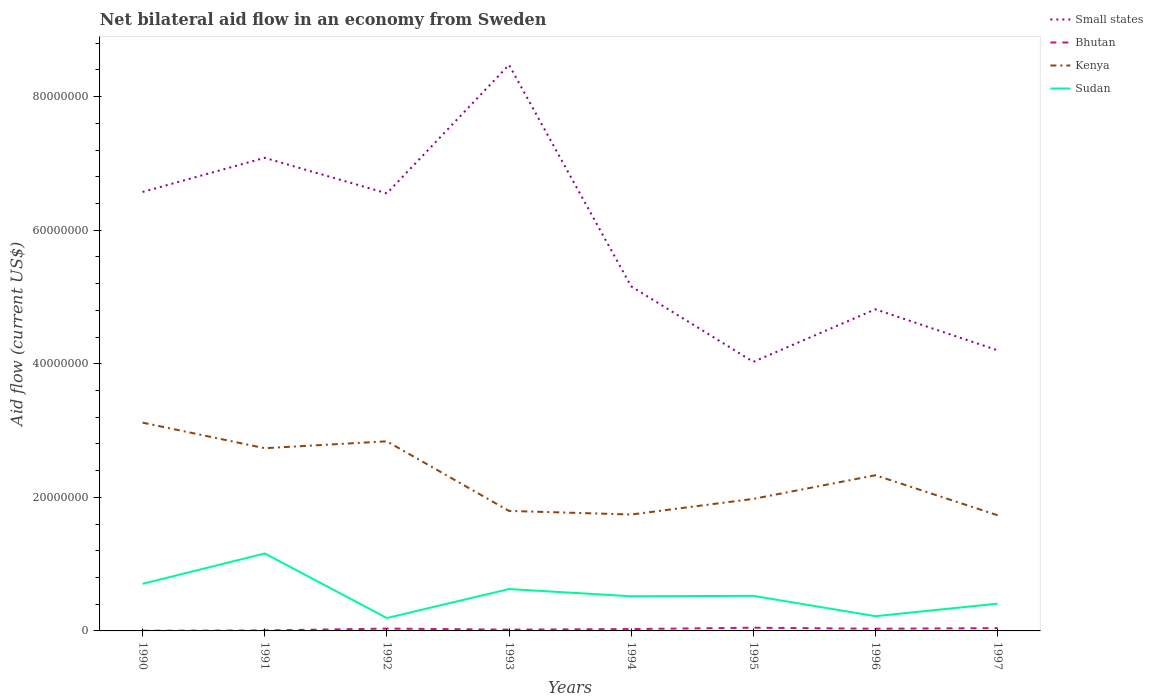Across all years, what is the maximum net bilateral aid flow in Small states?
Make the answer very short. 4.03e+07. What is the total net bilateral aid flow in Kenya in the graph?
Keep it short and to the point. 5.40e+05. What is the difference between the highest and the second highest net bilateral aid flow in Kenya?
Ensure brevity in your answer.  1.39e+07. What is the difference between the highest and the lowest net bilateral aid flow in Sudan?
Offer a very short reply. 3. How many lines are there?
Provide a succinct answer. 4. Where does the legend appear in the graph?
Keep it short and to the point. Top right. How are the legend labels stacked?
Keep it short and to the point. Vertical. What is the title of the graph?
Keep it short and to the point. Net bilateral aid flow in an economy from Sweden. What is the Aid flow (current US$) in Small states in 1990?
Your answer should be very brief. 6.57e+07. What is the Aid flow (current US$) of Bhutan in 1990?
Your answer should be compact. 3.00e+04. What is the Aid flow (current US$) in Kenya in 1990?
Your response must be concise. 3.12e+07. What is the Aid flow (current US$) in Sudan in 1990?
Your response must be concise. 7.05e+06. What is the Aid flow (current US$) in Small states in 1991?
Your answer should be compact. 7.08e+07. What is the Aid flow (current US$) of Bhutan in 1991?
Provide a succinct answer. 7.00e+04. What is the Aid flow (current US$) of Kenya in 1991?
Offer a terse response. 2.74e+07. What is the Aid flow (current US$) in Sudan in 1991?
Provide a succinct answer. 1.16e+07. What is the Aid flow (current US$) in Small states in 1992?
Keep it short and to the point. 6.55e+07. What is the Aid flow (current US$) in Kenya in 1992?
Give a very brief answer. 2.84e+07. What is the Aid flow (current US$) in Sudan in 1992?
Give a very brief answer. 1.93e+06. What is the Aid flow (current US$) in Small states in 1993?
Provide a short and direct response. 8.48e+07. What is the Aid flow (current US$) of Kenya in 1993?
Your response must be concise. 1.80e+07. What is the Aid flow (current US$) in Sudan in 1993?
Offer a terse response. 6.27e+06. What is the Aid flow (current US$) in Small states in 1994?
Offer a terse response. 5.16e+07. What is the Aid flow (current US$) in Bhutan in 1994?
Offer a terse response. 2.80e+05. What is the Aid flow (current US$) of Kenya in 1994?
Provide a succinct answer. 1.74e+07. What is the Aid flow (current US$) in Sudan in 1994?
Provide a succinct answer. 5.19e+06. What is the Aid flow (current US$) of Small states in 1995?
Your answer should be very brief. 4.03e+07. What is the Aid flow (current US$) of Bhutan in 1995?
Make the answer very short. 4.80e+05. What is the Aid flow (current US$) of Kenya in 1995?
Your answer should be very brief. 1.98e+07. What is the Aid flow (current US$) of Sudan in 1995?
Offer a very short reply. 5.25e+06. What is the Aid flow (current US$) of Small states in 1996?
Provide a succinct answer. 4.82e+07. What is the Aid flow (current US$) of Bhutan in 1996?
Keep it short and to the point. 3.30e+05. What is the Aid flow (current US$) in Kenya in 1996?
Ensure brevity in your answer.  2.33e+07. What is the Aid flow (current US$) of Sudan in 1996?
Offer a very short reply. 2.21e+06. What is the Aid flow (current US$) in Small states in 1997?
Give a very brief answer. 4.20e+07. What is the Aid flow (current US$) in Bhutan in 1997?
Your response must be concise. 4.20e+05. What is the Aid flow (current US$) in Kenya in 1997?
Your answer should be compact. 1.73e+07. What is the Aid flow (current US$) in Sudan in 1997?
Your answer should be very brief. 4.08e+06. Across all years, what is the maximum Aid flow (current US$) in Small states?
Ensure brevity in your answer.  8.48e+07. Across all years, what is the maximum Aid flow (current US$) of Bhutan?
Your answer should be very brief. 4.80e+05. Across all years, what is the maximum Aid flow (current US$) in Kenya?
Your answer should be very brief. 3.12e+07. Across all years, what is the maximum Aid flow (current US$) of Sudan?
Keep it short and to the point. 1.16e+07. Across all years, what is the minimum Aid flow (current US$) in Small states?
Make the answer very short. 4.03e+07. Across all years, what is the minimum Aid flow (current US$) in Kenya?
Your answer should be compact. 1.73e+07. Across all years, what is the minimum Aid flow (current US$) in Sudan?
Make the answer very short. 1.93e+06. What is the total Aid flow (current US$) of Small states in the graph?
Your response must be concise. 4.69e+08. What is the total Aid flow (current US$) in Bhutan in the graph?
Offer a terse response. 2.15e+06. What is the total Aid flow (current US$) in Kenya in the graph?
Your response must be concise. 1.83e+08. What is the total Aid flow (current US$) of Sudan in the graph?
Your answer should be compact. 4.36e+07. What is the difference between the Aid flow (current US$) in Small states in 1990 and that in 1991?
Provide a short and direct response. -5.11e+06. What is the difference between the Aid flow (current US$) of Kenya in 1990 and that in 1991?
Your answer should be very brief. 3.83e+06. What is the difference between the Aid flow (current US$) in Sudan in 1990 and that in 1991?
Provide a succinct answer. -4.55e+06. What is the difference between the Aid flow (current US$) in Small states in 1990 and that in 1992?
Your answer should be very brief. 2.10e+05. What is the difference between the Aid flow (current US$) in Bhutan in 1990 and that in 1992?
Make the answer very short. -3.20e+05. What is the difference between the Aid flow (current US$) of Kenya in 1990 and that in 1992?
Ensure brevity in your answer.  2.80e+06. What is the difference between the Aid flow (current US$) in Sudan in 1990 and that in 1992?
Offer a terse response. 5.12e+06. What is the difference between the Aid flow (current US$) of Small states in 1990 and that in 1993?
Ensure brevity in your answer.  -1.90e+07. What is the difference between the Aid flow (current US$) in Kenya in 1990 and that in 1993?
Provide a short and direct response. 1.32e+07. What is the difference between the Aid flow (current US$) in Sudan in 1990 and that in 1993?
Give a very brief answer. 7.80e+05. What is the difference between the Aid flow (current US$) in Small states in 1990 and that in 1994?
Offer a terse response. 1.41e+07. What is the difference between the Aid flow (current US$) in Bhutan in 1990 and that in 1994?
Your response must be concise. -2.50e+05. What is the difference between the Aid flow (current US$) of Kenya in 1990 and that in 1994?
Offer a terse response. 1.38e+07. What is the difference between the Aid flow (current US$) of Sudan in 1990 and that in 1994?
Make the answer very short. 1.86e+06. What is the difference between the Aid flow (current US$) in Small states in 1990 and that in 1995?
Keep it short and to the point. 2.54e+07. What is the difference between the Aid flow (current US$) in Bhutan in 1990 and that in 1995?
Your response must be concise. -4.50e+05. What is the difference between the Aid flow (current US$) of Kenya in 1990 and that in 1995?
Give a very brief answer. 1.14e+07. What is the difference between the Aid flow (current US$) of Sudan in 1990 and that in 1995?
Make the answer very short. 1.80e+06. What is the difference between the Aid flow (current US$) in Small states in 1990 and that in 1996?
Make the answer very short. 1.76e+07. What is the difference between the Aid flow (current US$) in Kenya in 1990 and that in 1996?
Ensure brevity in your answer.  7.88e+06. What is the difference between the Aid flow (current US$) in Sudan in 1990 and that in 1996?
Your answer should be compact. 4.84e+06. What is the difference between the Aid flow (current US$) in Small states in 1990 and that in 1997?
Offer a very short reply. 2.37e+07. What is the difference between the Aid flow (current US$) in Bhutan in 1990 and that in 1997?
Your response must be concise. -3.90e+05. What is the difference between the Aid flow (current US$) in Kenya in 1990 and that in 1997?
Your answer should be compact. 1.39e+07. What is the difference between the Aid flow (current US$) of Sudan in 1990 and that in 1997?
Provide a succinct answer. 2.97e+06. What is the difference between the Aid flow (current US$) in Small states in 1991 and that in 1992?
Provide a succinct answer. 5.32e+06. What is the difference between the Aid flow (current US$) of Bhutan in 1991 and that in 1992?
Make the answer very short. -2.80e+05. What is the difference between the Aid flow (current US$) in Kenya in 1991 and that in 1992?
Keep it short and to the point. -1.03e+06. What is the difference between the Aid flow (current US$) in Sudan in 1991 and that in 1992?
Provide a succinct answer. 9.67e+06. What is the difference between the Aid flow (current US$) of Small states in 1991 and that in 1993?
Offer a terse response. -1.39e+07. What is the difference between the Aid flow (current US$) in Bhutan in 1991 and that in 1993?
Your response must be concise. -1.20e+05. What is the difference between the Aid flow (current US$) of Kenya in 1991 and that in 1993?
Ensure brevity in your answer.  9.39e+06. What is the difference between the Aid flow (current US$) of Sudan in 1991 and that in 1993?
Keep it short and to the point. 5.33e+06. What is the difference between the Aid flow (current US$) in Small states in 1991 and that in 1994?
Offer a terse response. 1.92e+07. What is the difference between the Aid flow (current US$) in Kenya in 1991 and that in 1994?
Your answer should be very brief. 9.93e+06. What is the difference between the Aid flow (current US$) in Sudan in 1991 and that in 1994?
Your answer should be compact. 6.41e+06. What is the difference between the Aid flow (current US$) in Small states in 1991 and that in 1995?
Ensure brevity in your answer.  3.06e+07. What is the difference between the Aid flow (current US$) of Bhutan in 1991 and that in 1995?
Offer a terse response. -4.10e+05. What is the difference between the Aid flow (current US$) of Kenya in 1991 and that in 1995?
Provide a succinct answer. 7.59e+06. What is the difference between the Aid flow (current US$) in Sudan in 1991 and that in 1995?
Provide a short and direct response. 6.35e+06. What is the difference between the Aid flow (current US$) of Small states in 1991 and that in 1996?
Your answer should be very brief. 2.27e+07. What is the difference between the Aid flow (current US$) of Bhutan in 1991 and that in 1996?
Your response must be concise. -2.60e+05. What is the difference between the Aid flow (current US$) in Kenya in 1991 and that in 1996?
Give a very brief answer. 4.05e+06. What is the difference between the Aid flow (current US$) in Sudan in 1991 and that in 1996?
Your answer should be very brief. 9.39e+06. What is the difference between the Aid flow (current US$) in Small states in 1991 and that in 1997?
Offer a terse response. 2.88e+07. What is the difference between the Aid flow (current US$) in Bhutan in 1991 and that in 1997?
Offer a terse response. -3.50e+05. What is the difference between the Aid flow (current US$) of Kenya in 1991 and that in 1997?
Make the answer very short. 1.00e+07. What is the difference between the Aid flow (current US$) in Sudan in 1991 and that in 1997?
Offer a very short reply. 7.52e+06. What is the difference between the Aid flow (current US$) of Small states in 1992 and that in 1993?
Your answer should be very brief. -1.92e+07. What is the difference between the Aid flow (current US$) of Kenya in 1992 and that in 1993?
Your answer should be very brief. 1.04e+07. What is the difference between the Aid flow (current US$) of Sudan in 1992 and that in 1993?
Offer a terse response. -4.34e+06. What is the difference between the Aid flow (current US$) in Small states in 1992 and that in 1994?
Provide a short and direct response. 1.39e+07. What is the difference between the Aid flow (current US$) of Kenya in 1992 and that in 1994?
Your answer should be very brief. 1.10e+07. What is the difference between the Aid flow (current US$) in Sudan in 1992 and that in 1994?
Provide a short and direct response. -3.26e+06. What is the difference between the Aid flow (current US$) of Small states in 1992 and that in 1995?
Offer a terse response. 2.52e+07. What is the difference between the Aid flow (current US$) in Bhutan in 1992 and that in 1995?
Ensure brevity in your answer.  -1.30e+05. What is the difference between the Aid flow (current US$) in Kenya in 1992 and that in 1995?
Your answer should be compact. 8.62e+06. What is the difference between the Aid flow (current US$) of Sudan in 1992 and that in 1995?
Give a very brief answer. -3.32e+06. What is the difference between the Aid flow (current US$) in Small states in 1992 and that in 1996?
Provide a short and direct response. 1.74e+07. What is the difference between the Aid flow (current US$) in Kenya in 1992 and that in 1996?
Offer a terse response. 5.08e+06. What is the difference between the Aid flow (current US$) in Sudan in 1992 and that in 1996?
Offer a terse response. -2.80e+05. What is the difference between the Aid flow (current US$) of Small states in 1992 and that in 1997?
Make the answer very short. 2.35e+07. What is the difference between the Aid flow (current US$) in Bhutan in 1992 and that in 1997?
Offer a terse response. -7.00e+04. What is the difference between the Aid flow (current US$) in Kenya in 1992 and that in 1997?
Offer a very short reply. 1.11e+07. What is the difference between the Aid flow (current US$) in Sudan in 1992 and that in 1997?
Provide a short and direct response. -2.15e+06. What is the difference between the Aid flow (current US$) of Small states in 1993 and that in 1994?
Your answer should be very brief. 3.32e+07. What is the difference between the Aid flow (current US$) of Bhutan in 1993 and that in 1994?
Provide a short and direct response. -9.00e+04. What is the difference between the Aid flow (current US$) in Kenya in 1993 and that in 1994?
Make the answer very short. 5.40e+05. What is the difference between the Aid flow (current US$) of Sudan in 1993 and that in 1994?
Provide a short and direct response. 1.08e+06. What is the difference between the Aid flow (current US$) in Small states in 1993 and that in 1995?
Ensure brevity in your answer.  4.45e+07. What is the difference between the Aid flow (current US$) of Bhutan in 1993 and that in 1995?
Offer a terse response. -2.90e+05. What is the difference between the Aid flow (current US$) in Kenya in 1993 and that in 1995?
Make the answer very short. -1.80e+06. What is the difference between the Aid flow (current US$) of Sudan in 1993 and that in 1995?
Provide a succinct answer. 1.02e+06. What is the difference between the Aid flow (current US$) of Small states in 1993 and that in 1996?
Provide a short and direct response. 3.66e+07. What is the difference between the Aid flow (current US$) in Kenya in 1993 and that in 1996?
Make the answer very short. -5.34e+06. What is the difference between the Aid flow (current US$) in Sudan in 1993 and that in 1996?
Your answer should be very brief. 4.06e+06. What is the difference between the Aid flow (current US$) of Small states in 1993 and that in 1997?
Your response must be concise. 4.27e+07. What is the difference between the Aid flow (current US$) of Kenya in 1993 and that in 1997?
Offer a very short reply. 6.50e+05. What is the difference between the Aid flow (current US$) of Sudan in 1993 and that in 1997?
Your answer should be very brief. 2.19e+06. What is the difference between the Aid flow (current US$) of Small states in 1994 and that in 1995?
Your answer should be compact. 1.13e+07. What is the difference between the Aid flow (current US$) of Kenya in 1994 and that in 1995?
Offer a very short reply. -2.34e+06. What is the difference between the Aid flow (current US$) in Small states in 1994 and that in 1996?
Keep it short and to the point. 3.44e+06. What is the difference between the Aid flow (current US$) in Kenya in 1994 and that in 1996?
Provide a short and direct response. -5.88e+06. What is the difference between the Aid flow (current US$) in Sudan in 1994 and that in 1996?
Provide a succinct answer. 2.98e+06. What is the difference between the Aid flow (current US$) in Small states in 1994 and that in 1997?
Offer a very short reply. 9.58e+06. What is the difference between the Aid flow (current US$) in Bhutan in 1994 and that in 1997?
Provide a succinct answer. -1.40e+05. What is the difference between the Aid flow (current US$) of Sudan in 1994 and that in 1997?
Your answer should be very brief. 1.11e+06. What is the difference between the Aid flow (current US$) in Small states in 1995 and that in 1996?
Ensure brevity in your answer.  -7.87e+06. What is the difference between the Aid flow (current US$) in Kenya in 1995 and that in 1996?
Your answer should be very brief. -3.54e+06. What is the difference between the Aid flow (current US$) of Sudan in 1995 and that in 1996?
Provide a succinct answer. 3.04e+06. What is the difference between the Aid flow (current US$) of Small states in 1995 and that in 1997?
Your response must be concise. -1.73e+06. What is the difference between the Aid flow (current US$) of Bhutan in 1995 and that in 1997?
Your response must be concise. 6.00e+04. What is the difference between the Aid flow (current US$) of Kenya in 1995 and that in 1997?
Provide a short and direct response. 2.45e+06. What is the difference between the Aid flow (current US$) of Sudan in 1995 and that in 1997?
Keep it short and to the point. 1.17e+06. What is the difference between the Aid flow (current US$) of Small states in 1996 and that in 1997?
Give a very brief answer. 6.14e+06. What is the difference between the Aid flow (current US$) of Bhutan in 1996 and that in 1997?
Ensure brevity in your answer.  -9.00e+04. What is the difference between the Aid flow (current US$) of Kenya in 1996 and that in 1997?
Keep it short and to the point. 5.99e+06. What is the difference between the Aid flow (current US$) in Sudan in 1996 and that in 1997?
Provide a short and direct response. -1.87e+06. What is the difference between the Aid flow (current US$) of Small states in 1990 and the Aid flow (current US$) of Bhutan in 1991?
Provide a succinct answer. 6.57e+07. What is the difference between the Aid flow (current US$) in Small states in 1990 and the Aid flow (current US$) in Kenya in 1991?
Offer a very short reply. 3.84e+07. What is the difference between the Aid flow (current US$) of Small states in 1990 and the Aid flow (current US$) of Sudan in 1991?
Give a very brief answer. 5.41e+07. What is the difference between the Aid flow (current US$) of Bhutan in 1990 and the Aid flow (current US$) of Kenya in 1991?
Offer a terse response. -2.73e+07. What is the difference between the Aid flow (current US$) in Bhutan in 1990 and the Aid flow (current US$) in Sudan in 1991?
Keep it short and to the point. -1.16e+07. What is the difference between the Aid flow (current US$) in Kenya in 1990 and the Aid flow (current US$) in Sudan in 1991?
Provide a short and direct response. 1.96e+07. What is the difference between the Aid flow (current US$) of Small states in 1990 and the Aid flow (current US$) of Bhutan in 1992?
Make the answer very short. 6.54e+07. What is the difference between the Aid flow (current US$) of Small states in 1990 and the Aid flow (current US$) of Kenya in 1992?
Your answer should be compact. 3.73e+07. What is the difference between the Aid flow (current US$) in Small states in 1990 and the Aid flow (current US$) in Sudan in 1992?
Keep it short and to the point. 6.38e+07. What is the difference between the Aid flow (current US$) of Bhutan in 1990 and the Aid flow (current US$) of Kenya in 1992?
Make the answer very short. -2.84e+07. What is the difference between the Aid flow (current US$) of Bhutan in 1990 and the Aid flow (current US$) of Sudan in 1992?
Provide a short and direct response. -1.90e+06. What is the difference between the Aid flow (current US$) in Kenya in 1990 and the Aid flow (current US$) in Sudan in 1992?
Give a very brief answer. 2.93e+07. What is the difference between the Aid flow (current US$) in Small states in 1990 and the Aid flow (current US$) in Bhutan in 1993?
Keep it short and to the point. 6.55e+07. What is the difference between the Aid flow (current US$) of Small states in 1990 and the Aid flow (current US$) of Kenya in 1993?
Keep it short and to the point. 4.78e+07. What is the difference between the Aid flow (current US$) in Small states in 1990 and the Aid flow (current US$) in Sudan in 1993?
Provide a short and direct response. 5.95e+07. What is the difference between the Aid flow (current US$) of Bhutan in 1990 and the Aid flow (current US$) of Kenya in 1993?
Offer a terse response. -1.79e+07. What is the difference between the Aid flow (current US$) in Bhutan in 1990 and the Aid flow (current US$) in Sudan in 1993?
Your response must be concise. -6.24e+06. What is the difference between the Aid flow (current US$) in Kenya in 1990 and the Aid flow (current US$) in Sudan in 1993?
Offer a very short reply. 2.49e+07. What is the difference between the Aid flow (current US$) of Small states in 1990 and the Aid flow (current US$) of Bhutan in 1994?
Make the answer very short. 6.54e+07. What is the difference between the Aid flow (current US$) of Small states in 1990 and the Aid flow (current US$) of Kenya in 1994?
Give a very brief answer. 4.83e+07. What is the difference between the Aid flow (current US$) of Small states in 1990 and the Aid flow (current US$) of Sudan in 1994?
Ensure brevity in your answer.  6.05e+07. What is the difference between the Aid flow (current US$) of Bhutan in 1990 and the Aid flow (current US$) of Kenya in 1994?
Give a very brief answer. -1.74e+07. What is the difference between the Aid flow (current US$) of Bhutan in 1990 and the Aid flow (current US$) of Sudan in 1994?
Offer a terse response. -5.16e+06. What is the difference between the Aid flow (current US$) of Kenya in 1990 and the Aid flow (current US$) of Sudan in 1994?
Your response must be concise. 2.60e+07. What is the difference between the Aid flow (current US$) in Small states in 1990 and the Aid flow (current US$) in Bhutan in 1995?
Offer a terse response. 6.52e+07. What is the difference between the Aid flow (current US$) in Small states in 1990 and the Aid flow (current US$) in Kenya in 1995?
Your answer should be very brief. 4.60e+07. What is the difference between the Aid flow (current US$) of Small states in 1990 and the Aid flow (current US$) of Sudan in 1995?
Ensure brevity in your answer.  6.05e+07. What is the difference between the Aid flow (current US$) in Bhutan in 1990 and the Aid flow (current US$) in Kenya in 1995?
Ensure brevity in your answer.  -1.97e+07. What is the difference between the Aid flow (current US$) in Bhutan in 1990 and the Aid flow (current US$) in Sudan in 1995?
Give a very brief answer. -5.22e+06. What is the difference between the Aid flow (current US$) of Kenya in 1990 and the Aid flow (current US$) of Sudan in 1995?
Provide a short and direct response. 2.59e+07. What is the difference between the Aid flow (current US$) in Small states in 1990 and the Aid flow (current US$) in Bhutan in 1996?
Keep it short and to the point. 6.54e+07. What is the difference between the Aid flow (current US$) in Small states in 1990 and the Aid flow (current US$) in Kenya in 1996?
Provide a succinct answer. 4.24e+07. What is the difference between the Aid flow (current US$) of Small states in 1990 and the Aid flow (current US$) of Sudan in 1996?
Your response must be concise. 6.35e+07. What is the difference between the Aid flow (current US$) in Bhutan in 1990 and the Aid flow (current US$) in Kenya in 1996?
Your answer should be compact. -2.33e+07. What is the difference between the Aid flow (current US$) in Bhutan in 1990 and the Aid flow (current US$) in Sudan in 1996?
Provide a succinct answer. -2.18e+06. What is the difference between the Aid flow (current US$) in Kenya in 1990 and the Aid flow (current US$) in Sudan in 1996?
Make the answer very short. 2.90e+07. What is the difference between the Aid flow (current US$) of Small states in 1990 and the Aid flow (current US$) of Bhutan in 1997?
Ensure brevity in your answer.  6.53e+07. What is the difference between the Aid flow (current US$) of Small states in 1990 and the Aid flow (current US$) of Kenya in 1997?
Offer a terse response. 4.84e+07. What is the difference between the Aid flow (current US$) of Small states in 1990 and the Aid flow (current US$) of Sudan in 1997?
Make the answer very short. 6.16e+07. What is the difference between the Aid flow (current US$) in Bhutan in 1990 and the Aid flow (current US$) in Kenya in 1997?
Ensure brevity in your answer.  -1.73e+07. What is the difference between the Aid flow (current US$) of Bhutan in 1990 and the Aid flow (current US$) of Sudan in 1997?
Your answer should be very brief. -4.05e+06. What is the difference between the Aid flow (current US$) of Kenya in 1990 and the Aid flow (current US$) of Sudan in 1997?
Give a very brief answer. 2.71e+07. What is the difference between the Aid flow (current US$) in Small states in 1991 and the Aid flow (current US$) in Bhutan in 1992?
Provide a succinct answer. 7.05e+07. What is the difference between the Aid flow (current US$) in Small states in 1991 and the Aid flow (current US$) in Kenya in 1992?
Your answer should be very brief. 4.24e+07. What is the difference between the Aid flow (current US$) in Small states in 1991 and the Aid flow (current US$) in Sudan in 1992?
Provide a short and direct response. 6.89e+07. What is the difference between the Aid flow (current US$) of Bhutan in 1991 and the Aid flow (current US$) of Kenya in 1992?
Keep it short and to the point. -2.83e+07. What is the difference between the Aid flow (current US$) of Bhutan in 1991 and the Aid flow (current US$) of Sudan in 1992?
Offer a very short reply. -1.86e+06. What is the difference between the Aid flow (current US$) of Kenya in 1991 and the Aid flow (current US$) of Sudan in 1992?
Provide a succinct answer. 2.54e+07. What is the difference between the Aid flow (current US$) of Small states in 1991 and the Aid flow (current US$) of Bhutan in 1993?
Keep it short and to the point. 7.06e+07. What is the difference between the Aid flow (current US$) of Small states in 1991 and the Aid flow (current US$) of Kenya in 1993?
Give a very brief answer. 5.29e+07. What is the difference between the Aid flow (current US$) in Small states in 1991 and the Aid flow (current US$) in Sudan in 1993?
Provide a short and direct response. 6.46e+07. What is the difference between the Aid flow (current US$) of Bhutan in 1991 and the Aid flow (current US$) of Kenya in 1993?
Your answer should be compact. -1.79e+07. What is the difference between the Aid flow (current US$) in Bhutan in 1991 and the Aid flow (current US$) in Sudan in 1993?
Your answer should be compact. -6.20e+06. What is the difference between the Aid flow (current US$) of Kenya in 1991 and the Aid flow (current US$) of Sudan in 1993?
Make the answer very short. 2.11e+07. What is the difference between the Aid flow (current US$) of Small states in 1991 and the Aid flow (current US$) of Bhutan in 1994?
Your answer should be very brief. 7.06e+07. What is the difference between the Aid flow (current US$) in Small states in 1991 and the Aid flow (current US$) in Kenya in 1994?
Give a very brief answer. 5.34e+07. What is the difference between the Aid flow (current US$) of Small states in 1991 and the Aid flow (current US$) of Sudan in 1994?
Ensure brevity in your answer.  6.56e+07. What is the difference between the Aid flow (current US$) of Bhutan in 1991 and the Aid flow (current US$) of Kenya in 1994?
Your response must be concise. -1.74e+07. What is the difference between the Aid flow (current US$) of Bhutan in 1991 and the Aid flow (current US$) of Sudan in 1994?
Ensure brevity in your answer.  -5.12e+06. What is the difference between the Aid flow (current US$) of Kenya in 1991 and the Aid flow (current US$) of Sudan in 1994?
Provide a succinct answer. 2.22e+07. What is the difference between the Aid flow (current US$) in Small states in 1991 and the Aid flow (current US$) in Bhutan in 1995?
Provide a short and direct response. 7.04e+07. What is the difference between the Aid flow (current US$) in Small states in 1991 and the Aid flow (current US$) in Kenya in 1995?
Keep it short and to the point. 5.11e+07. What is the difference between the Aid flow (current US$) of Small states in 1991 and the Aid flow (current US$) of Sudan in 1995?
Your answer should be very brief. 6.56e+07. What is the difference between the Aid flow (current US$) of Bhutan in 1991 and the Aid flow (current US$) of Kenya in 1995?
Keep it short and to the point. -1.97e+07. What is the difference between the Aid flow (current US$) of Bhutan in 1991 and the Aid flow (current US$) of Sudan in 1995?
Ensure brevity in your answer.  -5.18e+06. What is the difference between the Aid flow (current US$) of Kenya in 1991 and the Aid flow (current US$) of Sudan in 1995?
Provide a short and direct response. 2.21e+07. What is the difference between the Aid flow (current US$) of Small states in 1991 and the Aid flow (current US$) of Bhutan in 1996?
Offer a terse response. 7.05e+07. What is the difference between the Aid flow (current US$) of Small states in 1991 and the Aid flow (current US$) of Kenya in 1996?
Your response must be concise. 4.75e+07. What is the difference between the Aid flow (current US$) in Small states in 1991 and the Aid flow (current US$) in Sudan in 1996?
Keep it short and to the point. 6.86e+07. What is the difference between the Aid flow (current US$) in Bhutan in 1991 and the Aid flow (current US$) in Kenya in 1996?
Make the answer very short. -2.32e+07. What is the difference between the Aid flow (current US$) in Bhutan in 1991 and the Aid flow (current US$) in Sudan in 1996?
Keep it short and to the point. -2.14e+06. What is the difference between the Aid flow (current US$) in Kenya in 1991 and the Aid flow (current US$) in Sudan in 1996?
Keep it short and to the point. 2.52e+07. What is the difference between the Aid flow (current US$) in Small states in 1991 and the Aid flow (current US$) in Bhutan in 1997?
Offer a very short reply. 7.04e+07. What is the difference between the Aid flow (current US$) in Small states in 1991 and the Aid flow (current US$) in Kenya in 1997?
Your answer should be very brief. 5.35e+07. What is the difference between the Aid flow (current US$) of Small states in 1991 and the Aid flow (current US$) of Sudan in 1997?
Your answer should be very brief. 6.68e+07. What is the difference between the Aid flow (current US$) in Bhutan in 1991 and the Aid flow (current US$) in Kenya in 1997?
Provide a succinct answer. -1.72e+07. What is the difference between the Aid flow (current US$) of Bhutan in 1991 and the Aid flow (current US$) of Sudan in 1997?
Your answer should be very brief. -4.01e+06. What is the difference between the Aid flow (current US$) of Kenya in 1991 and the Aid flow (current US$) of Sudan in 1997?
Your answer should be very brief. 2.33e+07. What is the difference between the Aid flow (current US$) in Small states in 1992 and the Aid flow (current US$) in Bhutan in 1993?
Ensure brevity in your answer.  6.53e+07. What is the difference between the Aid flow (current US$) in Small states in 1992 and the Aid flow (current US$) in Kenya in 1993?
Keep it short and to the point. 4.76e+07. What is the difference between the Aid flow (current US$) in Small states in 1992 and the Aid flow (current US$) in Sudan in 1993?
Keep it short and to the point. 5.92e+07. What is the difference between the Aid flow (current US$) in Bhutan in 1992 and the Aid flow (current US$) in Kenya in 1993?
Provide a short and direct response. -1.76e+07. What is the difference between the Aid flow (current US$) in Bhutan in 1992 and the Aid flow (current US$) in Sudan in 1993?
Make the answer very short. -5.92e+06. What is the difference between the Aid flow (current US$) of Kenya in 1992 and the Aid flow (current US$) of Sudan in 1993?
Your answer should be very brief. 2.21e+07. What is the difference between the Aid flow (current US$) in Small states in 1992 and the Aid flow (current US$) in Bhutan in 1994?
Keep it short and to the point. 6.52e+07. What is the difference between the Aid flow (current US$) of Small states in 1992 and the Aid flow (current US$) of Kenya in 1994?
Offer a very short reply. 4.81e+07. What is the difference between the Aid flow (current US$) of Small states in 1992 and the Aid flow (current US$) of Sudan in 1994?
Give a very brief answer. 6.03e+07. What is the difference between the Aid flow (current US$) of Bhutan in 1992 and the Aid flow (current US$) of Kenya in 1994?
Provide a succinct answer. -1.71e+07. What is the difference between the Aid flow (current US$) in Bhutan in 1992 and the Aid flow (current US$) in Sudan in 1994?
Give a very brief answer. -4.84e+06. What is the difference between the Aid flow (current US$) of Kenya in 1992 and the Aid flow (current US$) of Sudan in 1994?
Provide a short and direct response. 2.32e+07. What is the difference between the Aid flow (current US$) of Small states in 1992 and the Aid flow (current US$) of Bhutan in 1995?
Your answer should be very brief. 6.50e+07. What is the difference between the Aid flow (current US$) in Small states in 1992 and the Aid flow (current US$) in Kenya in 1995?
Make the answer very short. 4.58e+07. What is the difference between the Aid flow (current US$) in Small states in 1992 and the Aid flow (current US$) in Sudan in 1995?
Provide a short and direct response. 6.03e+07. What is the difference between the Aid flow (current US$) of Bhutan in 1992 and the Aid flow (current US$) of Kenya in 1995?
Offer a terse response. -1.94e+07. What is the difference between the Aid flow (current US$) of Bhutan in 1992 and the Aid flow (current US$) of Sudan in 1995?
Your answer should be very brief. -4.90e+06. What is the difference between the Aid flow (current US$) of Kenya in 1992 and the Aid flow (current US$) of Sudan in 1995?
Your answer should be compact. 2.31e+07. What is the difference between the Aid flow (current US$) of Small states in 1992 and the Aid flow (current US$) of Bhutan in 1996?
Your answer should be very brief. 6.52e+07. What is the difference between the Aid flow (current US$) of Small states in 1992 and the Aid flow (current US$) of Kenya in 1996?
Make the answer very short. 4.22e+07. What is the difference between the Aid flow (current US$) of Small states in 1992 and the Aid flow (current US$) of Sudan in 1996?
Offer a very short reply. 6.33e+07. What is the difference between the Aid flow (current US$) in Bhutan in 1992 and the Aid flow (current US$) in Kenya in 1996?
Your answer should be compact. -2.30e+07. What is the difference between the Aid flow (current US$) of Bhutan in 1992 and the Aid flow (current US$) of Sudan in 1996?
Make the answer very short. -1.86e+06. What is the difference between the Aid flow (current US$) of Kenya in 1992 and the Aid flow (current US$) of Sudan in 1996?
Give a very brief answer. 2.62e+07. What is the difference between the Aid flow (current US$) in Small states in 1992 and the Aid flow (current US$) in Bhutan in 1997?
Offer a terse response. 6.51e+07. What is the difference between the Aid flow (current US$) in Small states in 1992 and the Aid flow (current US$) in Kenya in 1997?
Keep it short and to the point. 4.82e+07. What is the difference between the Aid flow (current US$) of Small states in 1992 and the Aid flow (current US$) of Sudan in 1997?
Offer a terse response. 6.14e+07. What is the difference between the Aid flow (current US$) of Bhutan in 1992 and the Aid flow (current US$) of Kenya in 1997?
Your response must be concise. -1.70e+07. What is the difference between the Aid flow (current US$) in Bhutan in 1992 and the Aid flow (current US$) in Sudan in 1997?
Make the answer very short. -3.73e+06. What is the difference between the Aid flow (current US$) in Kenya in 1992 and the Aid flow (current US$) in Sudan in 1997?
Your response must be concise. 2.43e+07. What is the difference between the Aid flow (current US$) of Small states in 1993 and the Aid flow (current US$) of Bhutan in 1994?
Your response must be concise. 8.45e+07. What is the difference between the Aid flow (current US$) of Small states in 1993 and the Aid flow (current US$) of Kenya in 1994?
Ensure brevity in your answer.  6.73e+07. What is the difference between the Aid flow (current US$) in Small states in 1993 and the Aid flow (current US$) in Sudan in 1994?
Keep it short and to the point. 7.96e+07. What is the difference between the Aid flow (current US$) in Bhutan in 1993 and the Aid flow (current US$) in Kenya in 1994?
Provide a short and direct response. -1.72e+07. What is the difference between the Aid flow (current US$) in Bhutan in 1993 and the Aid flow (current US$) in Sudan in 1994?
Provide a succinct answer. -5.00e+06. What is the difference between the Aid flow (current US$) in Kenya in 1993 and the Aid flow (current US$) in Sudan in 1994?
Keep it short and to the point. 1.28e+07. What is the difference between the Aid flow (current US$) in Small states in 1993 and the Aid flow (current US$) in Bhutan in 1995?
Ensure brevity in your answer.  8.43e+07. What is the difference between the Aid flow (current US$) of Small states in 1993 and the Aid flow (current US$) of Kenya in 1995?
Keep it short and to the point. 6.50e+07. What is the difference between the Aid flow (current US$) of Small states in 1993 and the Aid flow (current US$) of Sudan in 1995?
Keep it short and to the point. 7.95e+07. What is the difference between the Aid flow (current US$) in Bhutan in 1993 and the Aid flow (current US$) in Kenya in 1995?
Your response must be concise. -1.96e+07. What is the difference between the Aid flow (current US$) of Bhutan in 1993 and the Aid flow (current US$) of Sudan in 1995?
Keep it short and to the point. -5.06e+06. What is the difference between the Aid flow (current US$) of Kenya in 1993 and the Aid flow (current US$) of Sudan in 1995?
Your response must be concise. 1.27e+07. What is the difference between the Aid flow (current US$) in Small states in 1993 and the Aid flow (current US$) in Bhutan in 1996?
Offer a very short reply. 8.44e+07. What is the difference between the Aid flow (current US$) of Small states in 1993 and the Aid flow (current US$) of Kenya in 1996?
Offer a terse response. 6.14e+07. What is the difference between the Aid flow (current US$) of Small states in 1993 and the Aid flow (current US$) of Sudan in 1996?
Your answer should be very brief. 8.26e+07. What is the difference between the Aid flow (current US$) of Bhutan in 1993 and the Aid flow (current US$) of Kenya in 1996?
Offer a terse response. -2.31e+07. What is the difference between the Aid flow (current US$) in Bhutan in 1993 and the Aid flow (current US$) in Sudan in 1996?
Provide a succinct answer. -2.02e+06. What is the difference between the Aid flow (current US$) of Kenya in 1993 and the Aid flow (current US$) of Sudan in 1996?
Provide a succinct answer. 1.58e+07. What is the difference between the Aid flow (current US$) of Small states in 1993 and the Aid flow (current US$) of Bhutan in 1997?
Provide a succinct answer. 8.43e+07. What is the difference between the Aid flow (current US$) of Small states in 1993 and the Aid flow (current US$) of Kenya in 1997?
Your answer should be compact. 6.74e+07. What is the difference between the Aid flow (current US$) in Small states in 1993 and the Aid flow (current US$) in Sudan in 1997?
Make the answer very short. 8.07e+07. What is the difference between the Aid flow (current US$) of Bhutan in 1993 and the Aid flow (current US$) of Kenya in 1997?
Your answer should be compact. -1.71e+07. What is the difference between the Aid flow (current US$) of Bhutan in 1993 and the Aid flow (current US$) of Sudan in 1997?
Your answer should be compact. -3.89e+06. What is the difference between the Aid flow (current US$) of Kenya in 1993 and the Aid flow (current US$) of Sudan in 1997?
Your response must be concise. 1.39e+07. What is the difference between the Aid flow (current US$) of Small states in 1994 and the Aid flow (current US$) of Bhutan in 1995?
Your answer should be compact. 5.11e+07. What is the difference between the Aid flow (current US$) in Small states in 1994 and the Aid flow (current US$) in Kenya in 1995?
Keep it short and to the point. 3.18e+07. What is the difference between the Aid flow (current US$) in Small states in 1994 and the Aid flow (current US$) in Sudan in 1995?
Keep it short and to the point. 4.64e+07. What is the difference between the Aid flow (current US$) in Bhutan in 1994 and the Aid flow (current US$) in Kenya in 1995?
Give a very brief answer. -1.95e+07. What is the difference between the Aid flow (current US$) in Bhutan in 1994 and the Aid flow (current US$) in Sudan in 1995?
Keep it short and to the point. -4.97e+06. What is the difference between the Aid flow (current US$) in Kenya in 1994 and the Aid flow (current US$) in Sudan in 1995?
Make the answer very short. 1.22e+07. What is the difference between the Aid flow (current US$) of Small states in 1994 and the Aid flow (current US$) of Bhutan in 1996?
Your answer should be very brief. 5.13e+07. What is the difference between the Aid flow (current US$) in Small states in 1994 and the Aid flow (current US$) in Kenya in 1996?
Ensure brevity in your answer.  2.83e+07. What is the difference between the Aid flow (current US$) of Small states in 1994 and the Aid flow (current US$) of Sudan in 1996?
Give a very brief answer. 4.94e+07. What is the difference between the Aid flow (current US$) of Bhutan in 1994 and the Aid flow (current US$) of Kenya in 1996?
Your answer should be very brief. -2.30e+07. What is the difference between the Aid flow (current US$) in Bhutan in 1994 and the Aid flow (current US$) in Sudan in 1996?
Keep it short and to the point. -1.93e+06. What is the difference between the Aid flow (current US$) in Kenya in 1994 and the Aid flow (current US$) in Sudan in 1996?
Ensure brevity in your answer.  1.52e+07. What is the difference between the Aid flow (current US$) in Small states in 1994 and the Aid flow (current US$) in Bhutan in 1997?
Offer a very short reply. 5.12e+07. What is the difference between the Aid flow (current US$) in Small states in 1994 and the Aid flow (current US$) in Kenya in 1997?
Offer a terse response. 3.43e+07. What is the difference between the Aid flow (current US$) of Small states in 1994 and the Aid flow (current US$) of Sudan in 1997?
Offer a very short reply. 4.75e+07. What is the difference between the Aid flow (current US$) of Bhutan in 1994 and the Aid flow (current US$) of Kenya in 1997?
Offer a very short reply. -1.70e+07. What is the difference between the Aid flow (current US$) of Bhutan in 1994 and the Aid flow (current US$) of Sudan in 1997?
Offer a terse response. -3.80e+06. What is the difference between the Aid flow (current US$) in Kenya in 1994 and the Aid flow (current US$) in Sudan in 1997?
Your response must be concise. 1.34e+07. What is the difference between the Aid flow (current US$) in Small states in 1995 and the Aid flow (current US$) in Bhutan in 1996?
Keep it short and to the point. 4.00e+07. What is the difference between the Aid flow (current US$) of Small states in 1995 and the Aid flow (current US$) of Kenya in 1996?
Ensure brevity in your answer.  1.70e+07. What is the difference between the Aid flow (current US$) in Small states in 1995 and the Aid flow (current US$) in Sudan in 1996?
Provide a succinct answer. 3.81e+07. What is the difference between the Aid flow (current US$) in Bhutan in 1995 and the Aid flow (current US$) in Kenya in 1996?
Ensure brevity in your answer.  -2.28e+07. What is the difference between the Aid flow (current US$) of Bhutan in 1995 and the Aid flow (current US$) of Sudan in 1996?
Your response must be concise. -1.73e+06. What is the difference between the Aid flow (current US$) in Kenya in 1995 and the Aid flow (current US$) in Sudan in 1996?
Ensure brevity in your answer.  1.76e+07. What is the difference between the Aid flow (current US$) in Small states in 1995 and the Aid flow (current US$) in Bhutan in 1997?
Provide a succinct answer. 3.99e+07. What is the difference between the Aid flow (current US$) in Small states in 1995 and the Aid flow (current US$) in Kenya in 1997?
Provide a succinct answer. 2.30e+07. What is the difference between the Aid flow (current US$) in Small states in 1995 and the Aid flow (current US$) in Sudan in 1997?
Ensure brevity in your answer.  3.62e+07. What is the difference between the Aid flow (current US$) in Bhutan in 1995 and the Aid flow (current US$) in Kenya in 1997?
Ensure brevity in your answer.  -1.68e+07. What is the difference between the Aid flow (current US$) of Bhutan in 1995 and the Aid flow (current US$) of Sudan in 1997?
Give a very brief answer. -3.60e+06. What is the difference between the Aid flow (current US$) in Kenya in 1995 and the Aid flow (current US$) in Sudan in 1997?
Offer a very short reply. 1.57e+07. What is the difference between the Aid flow (current US$) of Small states in 1996 and the Aid flow (current US$) of Bhutan in 1997?
Keep it short and to the point. 4.77e+07. What is the difference between the Aid flow (current US$) of Small states in 1996 and the Aid flow (current US$) of Kenya in 1997?
Your answer should be very brief. 3.08e+07. What is the difference between the Aid flow (current US$) in Small states in 1996 and the Aid flow (current US$) in Sudan in 1997?
Provide a succinct answer. 4.41e+07. What is the difference between the Aid flow (current US$) in Bhutan in 1996 and the Aid flow (current US$) in Kenya in 1997?
Make the answer very short. -1.70e+07. What is the difference between the Aid flow (current US$) in Bhutan in 1996 and the Aid flow (current US$) in Sudan in 1997?
Keep it short and to the point. -3.75e+06. What is the difference between the Aid flow (current US$) of Kenya in 1996 and the Aid flow (current US$) of Sudan in 1997?
Your answer should be very brief. 1.92e+07. What is the average Aid flow (current US$) in Small states per year?
Make the answer very short. 5.86e+07. What is the average Aid flow (current US$) in Bhutan per year?
Offer a very short reply. 2.69e+05. What is the average Aid flow (current US$) in Kenya per year?
Provide a short and direct response. 2.28e+07. What is the average Aid flow (current US$) in Sudan per year?
Provide a short and direct response. 5.45e+06. In the year 1990, what is the difference between the Aid flow (current US$) of Small states and Aid flow (current US$) of Bhutan?
Offer a very short reply. 6.57e+07. In the year 1990, what is the difference between the Aid flow (current US$) in Small states and Aid flow (current US$) in Kenya?
Keep it short and to the point. 3.45e+07. In the year 1990, what is the difference between the Aid flow (current US$) of Small states and Aid flow (current US$) of Sudan?
Offer a terse response. 5.87e+07. In the year 1990, what is the difference between the Aid flow (current US$) of Bhutan and Aid flow (current US$) of Kenya?
Ensure brevity in your answer.  -3.12e+07. In the year 1990, what is the difference between the Aid flow (current US$) in Bhutan and Aid flow (current US$) in Sudan?
Provide a short and direct response. -7.02e+06. In the year 1990, what is the difference between the Aid flow (current US$) of Kenya and Aid flow (current US$) of Sudan?
Keep it short and to the point. 2.41e+07. In the year 1991, what is the difference between the Aid flow (current US$) in Small states and Aid flow (current US$) in Bhutan?
Make the answer very short. 7.08e+07. In the year 1991, what is the difference between the Aid flow (current US$) of Small states and Aid flow (current US$) of Kenya?
Provide a succinct answer. 4.35e+07. In the year 1991, what is the difference between the Aid flow (current US$) of Small states and Aid flow (current US$) of Sudan?
Your response must be concise. 5.92e+07. In the year 1991, what is the difference between the Aid flow (current US$) in Bhutan and Aid flow (current US$) in Kenya?
Provide a short and direct response. -2.73e+07. In the year 1991, what is the difference between the Aid flow (current US$) of Bhutan and Aid flow (current US$) of Sudan?
Provide a succinct answer. -1.15e+07. In the year 1991, what is the difference between the Aid flow (current US$) in Kenya and Aid flow (current US$) in Sudan?
Provide a short and direct response. 1.58e+07. In the year 1992, what is the difference between the Aid flow (current US$) in Small states and Aid flow (current US$) in Bhutan?
Offer a terse response. 6.52e+07. In the year 1992, what is the difference between the Aid flow (current US$) in Small states and Aid flow (current US$) in Kenya?
Give a very brief answer. 3.71e+07. In the year 1992, what is the difference between the Aid flow (current US$) in Small states and Aid flow (current US$) in Sudan?
Your answer should be compact. 6.36e+07. In the year 1992, what is the difference between the Aid flow (current US$) in Bhutan and Aid flow (current US$) in Kenya?
Provide a succinct answer. -2.80e+07. In the year 1992, what is the difference between the Aid flow (current US$) of Bhutan and Aid flow (current US$) of Sudan?
Provide a succinct answer. -1.58e+06. In the year 1992, what is the difference between the Aid flow (current US$) in Kenya and Aid flow (current US$) in Sudan?
Your response must be concise. 2.65e+07. In the year 1993, what is the difference between the Aid flow (current US$) in Small states and Aid flow (current US$) in Bhutan?
Your answer should be compact. 8.46e+07. In the year 1993, what is the difference between the Aid flow (current US$) in Small states and Aid flow (current US$) in Kenya?
Your answer should be very brief. 6.68e+07. In the year 1993, what is the difference between the Aid flow (current US$) of Small states and Aid flow (current US$) of Sudan?
Your answer should be very brief. 7.85e+07. In the year 1993, what is the difference between the Aid flow (current US$) of Bhutan and Aid flow (current US$) of Kenya?
Provide a short and direct response. -1.78e+07. In the year 1993, what is the difference between the Aid flow (current US$) in Bhutan and Aid flow (current US$) in Sudan?
Your response must be concise. -6.08e+06. In the year 1993, what is the difference between the Aid flow (current US$) in Kenya and Aid flow (current US$) in Sudan?
Your answer should be compact. 1.17e+07. In the year 1994, what is the difference between the Aid flow (current US$) of Small states and Aid flow (current US$) of Bhutan?
Offer a terse response. 5.13e+07. In the year 1994, what is the difference between the Aid flow (current US$) in Small states and Aid flow (current US$) in Kenya?
Your answer should be very brief. 3.42e+07. In the year 1994, what is the difference between the Aid flow (current US$) of Small states and Aid flow (current US$) of Sudan?
Your answer should be compact. 4.64e+07. In the year 1994, what is the difference between the Aid flow (current US$) in Bhutan and Aid flow (current US$) in Kenya?
Keep it short and to the point. -1.72e+07. In the year 1994, what is the difference between the Aid flow (current US$) of Bhutan and Aid flow (current US$) of Sudan?
Your response must be concise. -4.91e+06. In the year 1994, what is the difference between the Aid flow (current US$) in Kenya and Aid flow (current US$) in Sudan?
Make the answer very short. 1.22e+07. In the year 1995, what is the difference between the Aid flow (current US$) in Small states and Aid flow (current US$) in Bhutan?
Ensure brevity in your answer.  3.98e+07. In the year 1995, what is the difference between the Aid flow (current US$) of Small states and Aid flow (current US$) of Kenya?
Keep it short and to the point. 2.05e+07. In the year 1995, what is the difference between the Aid flow (current US$) in Small states and Aid flow (current US$) in Sudan?
Provide a succinct answer. 3.50e+07. In the year 1995, what is the difference between the Aid flow (current US$) of Bhutan and Aid flow (current US$) of Kenya?
Make the answer very short. -1.93e+07. In the year 1995, what is the difference between the Aid flow (current US$) of Bhutan and Aid flow (current US$) of Sudan?
Provide a succinct answer. -4.77e+06. In the year 1995, what is the difference between the Aid flow (current US$) of Kenya and Aid flow (current US$) of Sudan?
Provide a short and direct response. 1.45e+07. In the year 1996, what is the difference between the Aid flow (current US$) in Small states and Aid flow (current US$) in Bhutan?
Give a very brief answer. 4.78e+07. In the year 1996, what is the difference between the Aid flow (current US$) of Small states and Aid flow (current US$) of Kenya?
Your answer should be very brief. 2.48e+07. In the year 1996, what is the difference between the Aid flow (current US$) in Small states and Aid flow (current US$) in Sudan?
Your answer should be very brief. 4.60e+07. In the year 1996, what is the difference between the Aid flow (current US$) of Bhutan and Aid flow (current US$) of Kenya?
Keep it short and to the point. -2.30e+07. In the year 1996, what is the difference between the Aid flow (current US$) in Bhutan and Aid flow (current US$) in Sudan?
Offer a very short reply. -1.88e+06. In the year 1996, what is the difference between the Aid flow (current US$) of Kenya and Aid flow (current US$) of Sudan?
Your answer should be compact. 2.11e+07. In the year 1997, what is the difference between the Aid flow (current US$) in Small states and Aid flow (current US$) in Bhutan?
Make the answer very short. 4.16e+07. In the year 1997, what is the difference between the Aid flow (current US$) in Small states and Aid flow (current US$) in Kenya?
Your response must be concise. 2.47e+07. In the year 1997, what is the difference between the Aid flow (current US$) of Small states and Aid flow (current US$) of Sudan?
Offer a very short reply. 3.79e+07. In the year 1997, what is the difference between the Aid flow (current US$) of Bhutan and Aid flow (current US$) of Kenya?
Provide a succinct answer. -1.69e+07. In the year 1997, what is the difference between the Aid flow (current US$) of Bhutan and Aid flow (current US$) of Sudan?
Your response must be concise. -3.66e+06. In the year 1997, what is the difference between the Aid flow (current US$) in Kenya and Aid flow (current US$) in Sudan?
Keep it short and to the point. 1.32e+07. What is the ratio of the Aid flow (current US$) in Small states in 1990 to that in 1991?
Your answer should be compact. 0.93. What is the ratio of the Aid flow (current US$) of Bhutan in 1990 to that in 1991?
Provide a succinct answer. 0.43. What is the ratio of the Aid flow (current US$) of Kenya in 1990 to that in 1991?
Give a very brief answer. 1.14. What is the ratio of the Aid flow (current US$) of Sudan in 1990 to that in 1991?
Your response must be concise. 0.61. What is the ratio of the Aid flow (current US$) in Small states in 1990 to that in 1992?
Keep it short and to the point. 1. What is the ratio of the Aid flow (current US$) in Bhutan in 1990 to that in 1992?
Provide a succinct answer. 0.09. What is the ratio of the Aid flow (current US$) in Kenya in 1990 to that in 1992?
Make the answer very short. 1.1. What is the ratio of the Aid flow (current US$) of Sudan in 1990 to that in 1992?
Make the answer very short. 3.65. What is the ratio of the Aid flow (current US$) in Small states in 1990 to that in 1993?
Provide a succinct answer. 0.78. What is the ratio of the Aid flow (current US$) in Bhutan in 1990 to that in 1993?
Keep it short and to the point. 0.16. What is the ratio of the Aid flow (current US$) in Kenya in 1990 to that in 1993?
Your response must be concise. 1.74. What is the ratio of the Aid flow (current US$) in Sudan in 1990 to that in 1993?
Provide a short and direct response. 1.12. What is the ratio of the Aid flow (current US$) in Small states in 1990 to that in 1994?
Your response must be concise. 1.27. What is the ratio of the Aid flow (current US$) of Bhutan in 1990 to that in 1994?
Make the answer very short. 0.11. What is the ratio of the Aid flow (current US$) of Kenya in 1990 to that in 1994?
Provide a short and direct response. 1.79. What is the ratio of the Aid flow (current US$) in Sudan in 1990 to that in 1994?
Provide a short and direct response. 1.36. What is the ratio of the Aid flow (current US$) of Small states in 1990 to that in 1995?
Your response must be concise. 1.63. What is the ratio of the Aid flow (current US$) of Bhutan in 1990 to that in 1995?
Your answer should be compact. 0.06. What is the ratio of the Aid flow (current US$) of Kenya in 1990 to that in 1995?
Offer a terse response. 1.58. What is the ratio of the Aid flow (current US$) in Sudan in 1990 to that in 1995?
Keep it short and to the point. 1.34. What is the ratio of the Aid flow (current US$) in Small states in 1990 to that in 1996?
Keep it short and to the point. 1.36. What is the ratio of the Aid flow (current US$) in Bhutan in 1990 to that in 1996?
Provide a succinct answer. 0.09. What is the ratio of the Aid flow (current US$) of Kenya in 1990 to that in 1996?
Make the answer very short. 1.34. What is the ratio of the Aid flow (current US$) of Sudan in 1990 to that in 1996?
Provide a succinct answer. 3.19. What is the ratio of the Aid flow (current US$) in Small states in 1990 to that in 1997?
Your answer should be compact. 1.56. What is the ratio of the Aid flow (current US$) of Bhutan in 1990 to that in 1997?
Make the answer very short. 0.07. What is the ratio of the Aid flow (current US$) of Kenya in 1990 to that in 1997?
Offer a terse response. 1.8. What is the ratio of the Aid flow (current US$) in Sudan in 1990 to that in 1997?
Offer a very short reply. 1.73. What is the ratio of the Aid flow (current US$) in Small states in 1991 to that in 1992?
Your response must be concise. 1.08. What is the ratio of the Aid flow (current US$) in Bhutan in 1991 to that in 1992?
Keep it short and to the point. 0.2. What is the ratio of the Aid flow (current US$) of Kenya in 1991 to that in 1992?
Your answer should be compact. 0.96. What is the ratio of the Aid flow (current US$) of Sudan in 1991 to that in 1992?
Your answer should be very brief. 6.01. What is the ratio of the Aid flow (current US$) of Small states in 1991 to that in 1993?
Offer a very short reply. 0.84. What is the ratio of the Aid flow (current US$) in Bhutan in 1991 to that in 1993?
Provide a succinct answer. 0.37. What is the ratio of the Aid flow (current US$) in Kenya in 1991 to that in 1993?
Your answer should be compact. 1.52. What is the ratio of the Aid flow (current US$) of Sudan in 1991 to that in 1993?
Provide a short and direct response. 1.85. What is the ratio of the Aid flow (current US$) in Small states in 1991 to that in 1994?
Ensure brevity in your answer.  1.37. What is the ratio of the Aid flow (current US$) in Bhutan in 1991 to that in 1994?
Ensure brevity in your answer.  0.25. What is the ratio of the Aid flow (current US$) in Kenya in 1991 to that in 1994?
Provide a short and direct response. 1.57. What is the ratio of the Aid flow (current US$) of Sudan in 1991 to that in 1994?
Provide a succinct answer. 2.24. What is the ratio of the Aid flow (current US$) of Small states in 1991 to that in 1995?
Make the answer very short. 1.76. What is the ratio of the Aid flow (current US$) of Bhutan in 1991 to that in 1995?
Provide a short and direct response. 0.15. What is the ratio of the Aid flow (current US$) of Kenya in 1991 to that in 1995?
Provide a succinct answer. 1.38. What is the ratio of the Aid flow (current US$) of Sudan in 1991 to that in 1995?
Provide a succinct answer. 2.21. What is the ratio of the Aid flow (current US$) of Small states in 1991 to that in 1996?
Ensure brevity in your answer.  1.47. What is the ratio of the Aid flow (current US$) in Bhutan in 1991 to that in 1996?
Offer a very short reply. 0.21. What is the ratio of the Aid flow (current US$) of Kenya in 1991 to that in 1996?
Your answer should be very brief. 1.17. What is the ratio of the Aid flow (current US$) of Sudan in 1991 to that in 1996?
Your answer should be very brief. 5.25. What is the ratio of the Aid flow (current US$) of Small states in 1991 to that in 1997?
Ensure brevity in your answer.  1.69. What is the ratio of the Aid flow (current US$) of Bhutan in 1991 to that in 1997?
Give a very brief answer. 0.17. What is the ratio of the Aid flow (current US$) in Kenya in 1991 to that in 1997?
Provide a short and direct response. 1.58. What is the ratio of the Aid flow (current US$) in Sudan in 1991 to that in 1997?
Offer a terse response. 2.84. What is the ratio of the Aid flow (current US$) of Small states in 1992 to that in 1993?
Ensure brevity in your answer.  0.77. What is the ratio of the Aid flow (current US$) in Bhutan in 1992 to that in 1993?
Provide a short and direct response. 1.84. What is the ratio of the Aid flow (current US$) in Kenya in 1992 to that in 1993?
Offer a terse response. 1.58. What is the ratio of the Aid flow (current US$) in Sudan in 1992 to that in 1993?
Offer a terse response. 0.31. What is the ratio of the Aid flow (current US$) of Small states in 1992 to that in 1994?
Your answer should be compact. 1.27. What is the ratio of the Aid flow (current US$) of Bhutan in 1992 to that in 1994?
Keep it short and to the point. 1.25. What is the ratio of the Aid flow (current US$) in Kenya in 1992 to that in 1994?
Provide a succinct answer. 1.63. What is the ratio of the Aid flow (current US$) in Sudan in 1992 to that in 1994?
Provide a short and direct response. 0.37. What is the ratio of the Aid flow (current US$) in Small states in 1992 to that in 1995?
Make the answer very short. 1.63. What is the ratio of the Aid flow (current US$) in Bhutan in 1992 to that in 1995?
Offer a very short reply. 0.73. What is the ratio of the Aid flow (current US$) in Kenya in 1992 to that in 1995?
Make the answer very short. 1.44. What is the ratio of the Aid flow (current US$) of Sudan in 1992 to that in 1995?
Offer a terse response. 0.37. What is the ratio of the Aid flow (current US$) in Small states in 1992 to that in 1996?
Give a very brief answer. 1.36. What is the ratio of the Aid flow (current US$) in Bhutan in 1992 to that in 1996?
Keep it short and to the point. 1.06. What is the ratio of the Aid flow (current US$) in Kenya in 1992 to that in 1996?
Ensure brevity in your answer.  1.22. What is the ratio of the Aid flow (current US$) of Sudan in 1992 to that in 1996?
Make the answer very short. 0.87. What is the ratio of the Aid flow (current US$) in Small states in 1992 to that in 1997?
Ensure brevity in your answer.  1.56. What is the ratio of the Aid flow (current US$) of Kenya in 1992 to that in 1997?
Ensure brevity in your answer.  1.64. What is the ratio of the Aid flow (current US$) of Sudan in 1992 to that in 1997?
Make the answer very short. 0.47. What is the ratio of the Aid flow (current US$) of Small states in 1993 to that in 1994?
Offer a terse response. 1.64. What is the ratio of the Aid flow (current US$) of Bhutan in 1993 to that in 1994?
Your answer should be very brief. 0.68. What is the ratio of the Aid flow (current US$) in Kenya in 1993 to that in 1994?
Your answer should be compact. 1.03. What is the ratio of the Aid flow (current US$) in Sudan in 1993 to that in 1994?
Ensure brevity in your answer.  1.21. What is the ratio of the Aid flow (current US$) of Small states in 1993 to that in 1995?
Keep it short and to the point. 2.1. What is the ratio of the Aid flow (current US$) of Bhutan in 1993 to that in 1995?
Offer a terse response. 0.4. What is the ratio of the Aid flow (current US$) of Kenya in 1993 to that in 1995?
Offer a terse response. 0.91. What is the ratio of the Aid flow (current US$) in Sudan in 1993 to that in 1995?
Your answer should be very brief. 1.19. What is the ratio of the Aid flow (current US$) in Small states in 1993 to that in 1996?
Make the answer very short. 1.76. What is the ratio of the Aid flow (current US$) in Bhutan in 1993 to that in 1996?
Your answer should be compact. 0.58. What is the ratio of the Aid flow (current US$) of Kenya in 1993 to that in 1996?
Offer a very short reply. 0.77. What is the ratio of the Aid flow (current US$) of Sudan in 1993 to that in 1996?
Your answer should be compact. 2.84. What is the ratio of the Aid flow (current US$) in Small states in 1993 to that in 1997?
Provide a short and direct response. 2.02. What is the ratio of the Aid flow (current US$) of Bhutan in 1993 to that in 1997?
Offer a very short reply. 0.45. What is the ratio of the Aid flow (current US$) of Kenya in 1993 to that in 1997?
Give a very brief answer. 1.04. What is the ratio of the Aid flow (current US$) of Sudan in 1993 to that in 1997?
Offer a terse response. 1.54. What is the ratio of the Aid flow (current US$) in Small states in 1994 to that in 1995?
Offer a very short reply. 1.28. What is the ratio of the Aid flow (current US$) of Bhutan in 1994 to that in 1995?
Offer a terse response. 0.58. What is the ratio of the Aid flow (current US$) of Kenya in 1994 to that in 1995?
Your answer should be compact. 0.88. What is the ratio of the Aid flow (current US$) of Sudan in 1994 to that in 1995?
Keep it short and to the point. 0.99. What is the ratio of the Aid flow (current US$) in Small states in 1994 to that in 1996?
Give a very brief answer. 1.07. What is the ratio of the Aid flow (current US$) of Bhutan in 1994 to that in 1996?
Your answer should be very brief. 0.85. What is the ratio of the Aid flow (current US$) of Kenya in 1994 to that in 1996?
Give a very brief answer. 0.75. What is the ratio of the Aid flow (current US$) of Sudan in 1994 to that in 1996?
Offer a terse response. 2.35. What is the ratio of the Aid flow (current US$) in Small states in 1994 to that in 1997?
Provide a succinct answer. 1.23. What is the ratio of the Aid flow (current US$) of Bhutan in 1994 to that in 1997?
Offer a very short reply. 0.67. What is the ratio of the Aid flow (current US$) of Kenya in 1994 to that in 1997?
Your response must be concise. 1.01. What is the ratio of the Aid flow (current US$) of Sudan in 1994 to that in 1997?
Keep it short and to the point. 1.27. What is the ratio of the Aid flow (current US$) of Small states in 1995 to that in 1996?
Your response must be concise. 0.84. What is the ratio of the Aid flow (current US$) in Bhutan in 1995 to that in 1996?
Your response must be concise. 1.45. What is the ratio of the Aid flow (current US$) of Kenya in 1995 to that in 1996?
Your response must be concise. 0.85. What is the ratio of the Aid flow (current US$) of Sudan in 1995 to that in 1996?
Ensure brevity in your answer.  2.38. What is the ratio of the Aid flow (current US$) of Small states in 1995 to that in 1997?
Offer a terse response. 0.96. What is the ratio of the Aid flow (current US$) in Kenya in 1995 to that in 1997?
Your response must be concise. 1.14. What is the ratio of the Aid flow (current US$) in Sudan in 1995 to that in 1997?
Make the answer very short. 1.29. What is the ratio of the Aid flow (current US$) in Small states in 1996 to that in 1997?
Your answer should be very brief. 1.15. What is the ratio of the Aid flow (current US$) in Bhutan in 1996 to that in 1997?
Offer a very short reply. 0.79. What is the ratio of the Aid flow (current US$) in Kenya in 1996 to that in 1997?
Offer a terse response. 1.35. What is the ratio of the Aid flow (current US$) in Sudan in 1996 to that in 1997?
Your response must be concise. 0.54. What is the difference between the highest and the second highest Aid flow (current US$) in Small states?
Ensure brevity in your answer.  1.39e+07. What is the difference between the highest and the second highest Aid flow (current US$) in Kenya?
Provide a short and direct response. 2.80e+06. What is the difference between the highest and the second highest Aid flow (current US$) in Sudan?
Your answer should be very brief. 4.55e+06. What is the difference between the highest and the lowest Aid flow (current US$) in Small states?
Your answer should be compact. 4.45e+07. What is the difference between the highest and the lowest Aid flow (current US$) of Bhutan?
Provide a succinct answer. 4.50e+05. What is the difference between the highest and the lowest Aid flow (current US$) in Kenya?
Give a very brief answer. 1.39e+07. What is the difference between the highest and the lowest Aid flow (current US$) in Sudan?
Keep it short and to the point. 9.67e+06. 